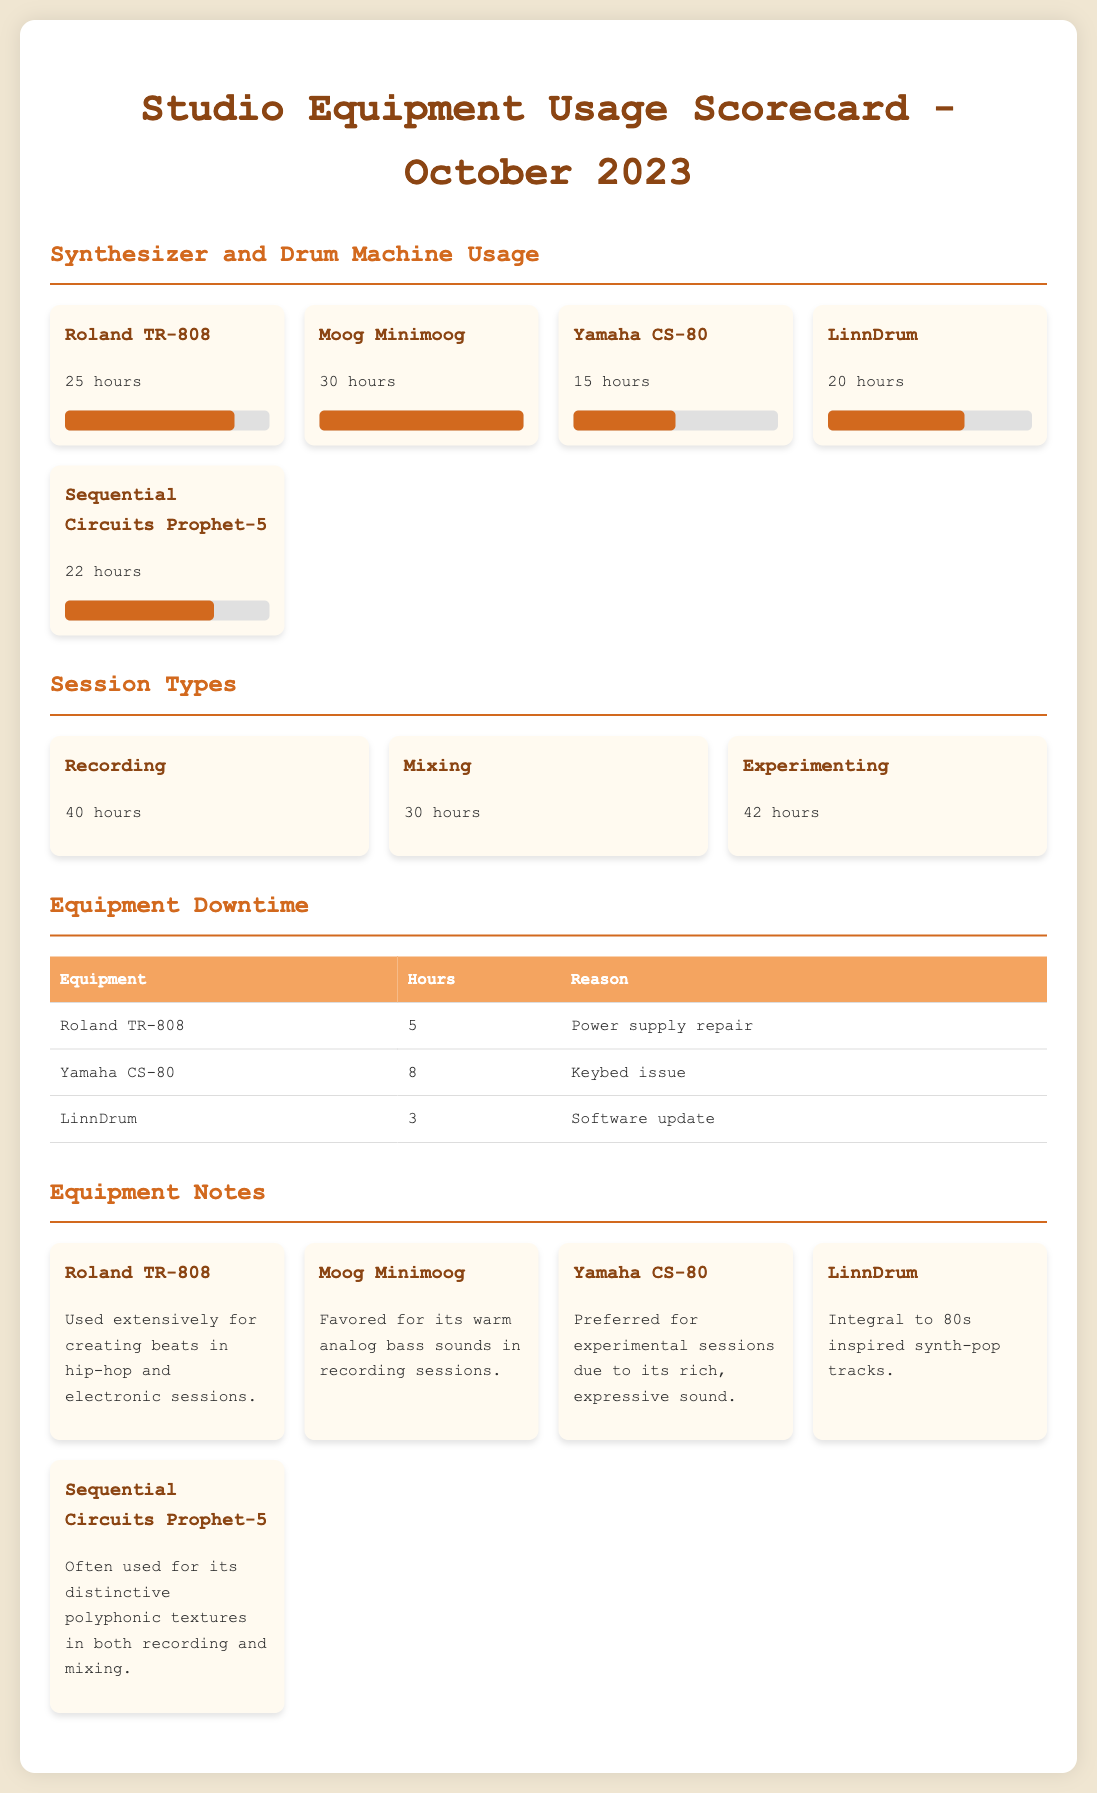What is the total usage time for Moog Minimoog? The usage time for Moog Minimoog is specified directly as 30 hours in the document.
Answer: 30 hours How many hours were spent on mixing sessions? The document shows that 30 hours were spent specifically on mixing sessions.
Answer: 30 hours What equipment had the longest downtime? By comparing the downtime hours listed, Yamaha CS-80 had the longest downtime due to keybed issues, totaling 8 hours.
Answer: Yamaha CS-80 Which session type had the highest total usage time? The total usage for experimenting sessions, which is 42 hours, exceeds other session types listed.
Answer: Experimenting What was the reason for LinnDrum's downtime? The document specifies that LinnDrum was down for a software update, which accounts for its 3 hours of downtime.
Answer: Software update How many hours were spent using the Roland TR-808? Roland TR-808 usage time is directly stated in the document as 25 hours.
Answer: 25 hours Which synthesizer is often used for polyphonic textures? The document mentions that Sequential Circuits Prophet-5 is often used for its distinctive polyphonic textures.
Answer: Sequential Circuits Prophet-5 What is the usage time of Yamaha CS-80 compared to that of LinnDrum? The document states Yamaha CS-80 was used for 15 hours and LinnDrum for 20 hours, indicating that LinnDrum had more usage time.
Answer: LinnDrum 